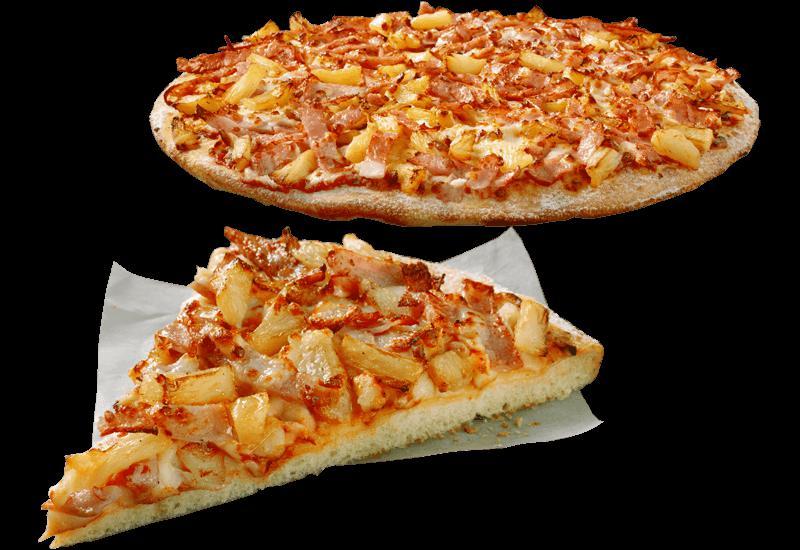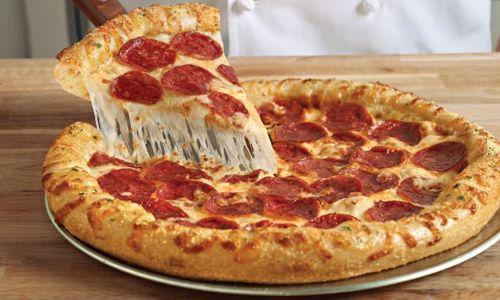The first image is the image on the left, the second image is the image on the right. Assess this claim about the two images: "The right image shows a slice of pizza lifted upward, with cheese stretching along its side, from a round pie, and the left image includes a whole round pizza.". Correct or not? Answer yes or no. Yes. The first image is the image on the left, the second image is the image on the right. Examine the images to the left and right. Is the description "One slice is being lifted off the pizza." accurate? Answer yes or no. Yes. 